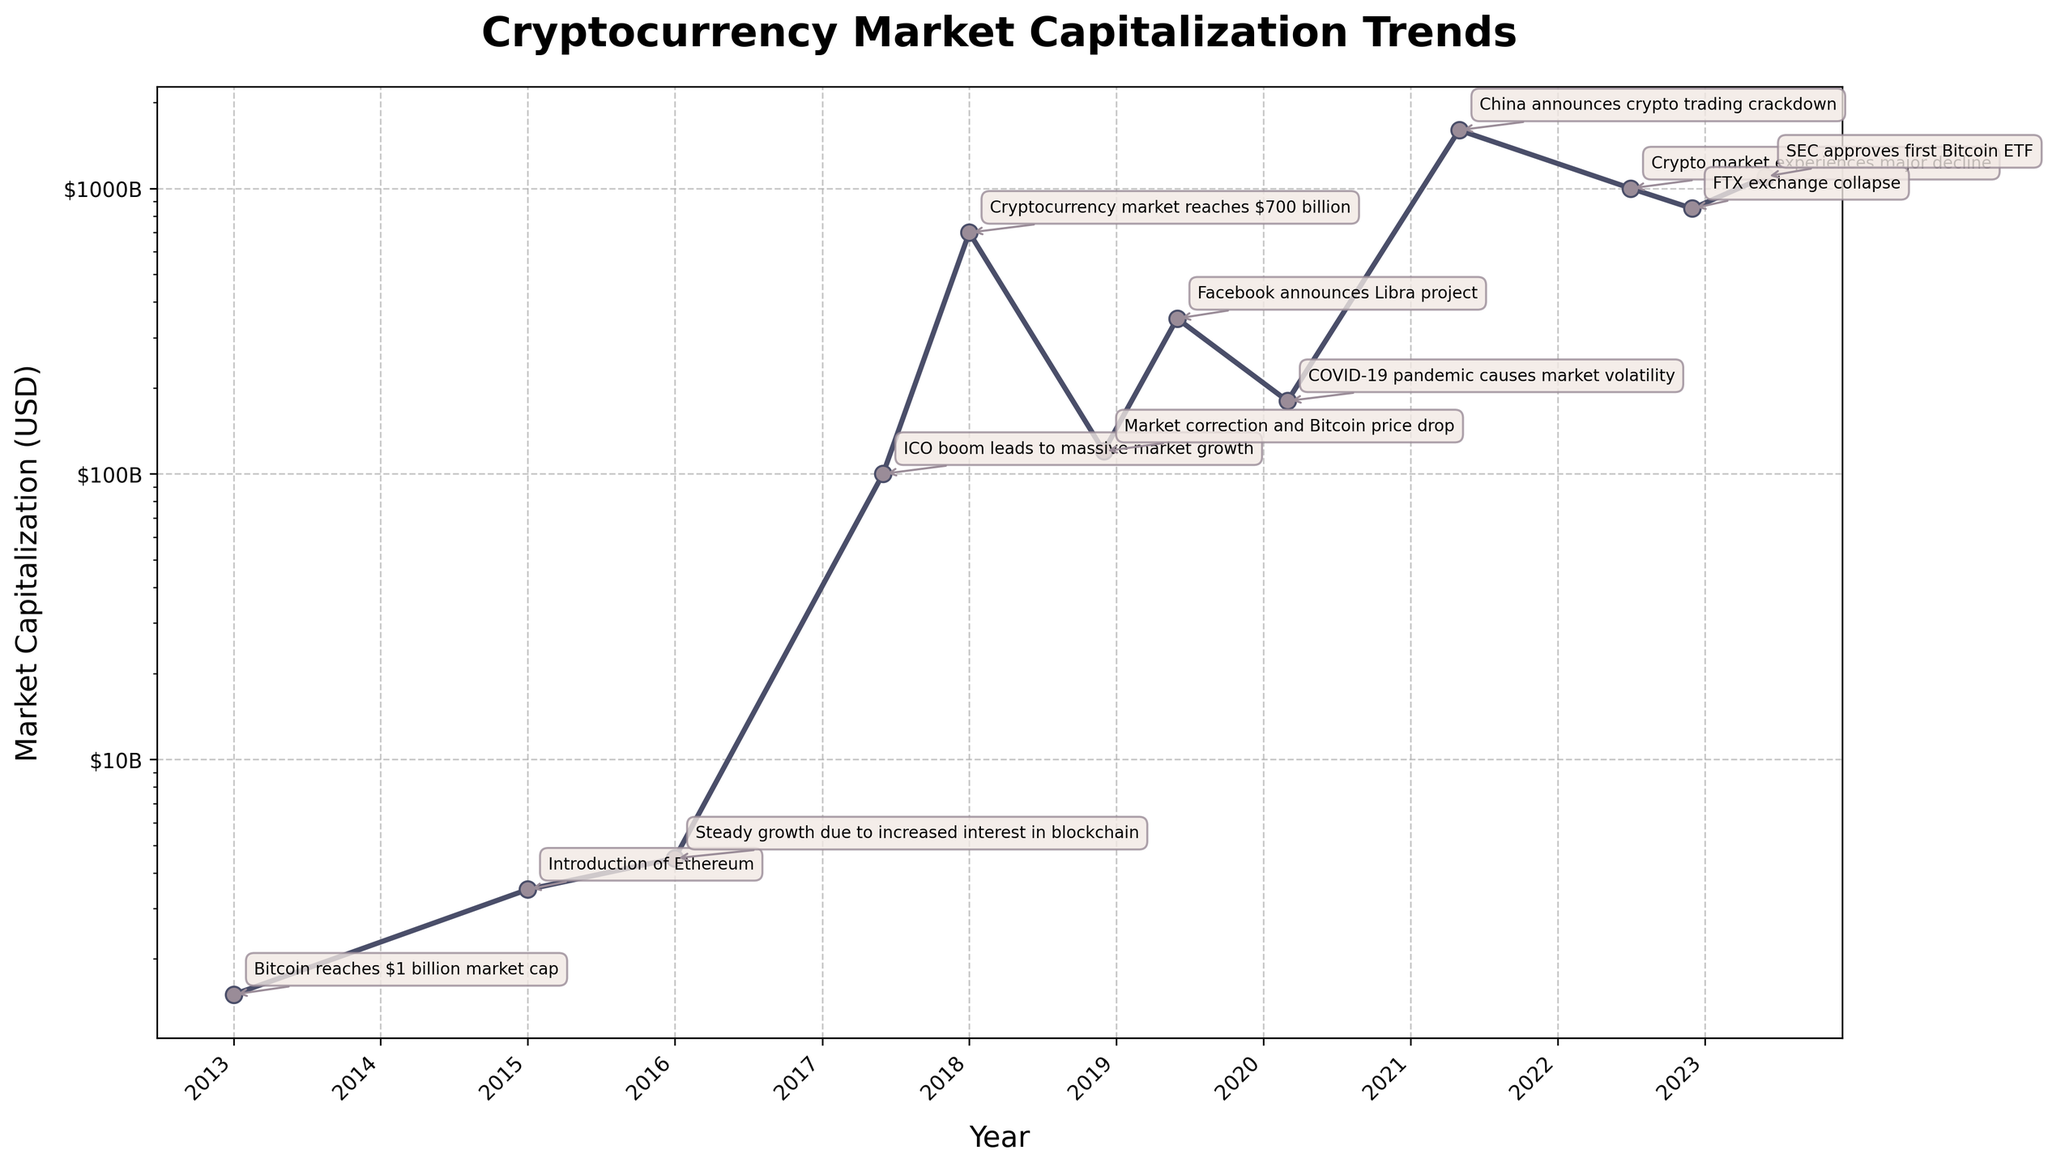What is the market capitalization of cryptocurrencies in January 2013? According to the plot, the market cap in January 2013 is marked with an annotation stating "Bitcoin reaches $1 billion market cap". The y-axis, which is also the market cap, shows around $1.5 billion.
Answer: $1.5 billion Which event corresponded with the market cap reaching approximately $700 billion? Looking at the figure, the event in January 2018 shows massive growth in the market cap to $700 billion. The annotation reads, "Cryptocurrency market reaches $700 billion."
Answer: Cryptocurrency market reaches $700 billion What is the title of the plot? The title of the plot, placed at the top center, is "Cryptocurrency Market Capitalization Trends."
Answer: Cryptocurrency Market Capitalization Trends By how much did the market cap decline from January 2018 to December 2018? The market cap in January 2018 was $700 billion. By December 2018, it had fallen to $120 billion. The decline can be calculated as $700 billion - $120 billion.
Answer: $580 billion When did China announce a crypto trading crackdown, and what was the market cap during that time? In May 2021, China announced a crypto trading crackdown, and the market cap then was approximately $1.6 trillion as per the visual annotations.
Answer: May 2021, $1.6 trillion Compare the market cap values for January 2015 and December 2022. Which one is higher and by how much? The market cap in January 2015 was $3.5 billion, and in December 2022, it was $850 billion. To find the difference, we calculate $850 billion - $3.5 billion.
Answer: December 2022 is higher by $846.5 billion What pattern can you observe from the overall trend of the market capitalization from 2013 to 2023? The plot shows an increasing trend with major peaks and troughs. There's significant growth in market cap until early 2018, a correction afterward, then a subsequent rise and fall in the following years.
Answer: Overall increasing trend with volatility When was the market cap at its lowest, and what was the value? The plot indicates that the lowest market cap occurred around January 2013, corresponding to a market cap of $1.5 billion.
Answer: January 2013, $1.5 billion What major event occurred in June 2019, and how did it affect the market cap? The event was "Facebook announces Libra project," which resulted in a market cap of approximately $350 billion as indicated by the annotated chart.
Answer: Facebook announces Libra project, $350 billion 